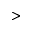Convert formula to latex. <formula><loc_0><loc_0><loc_500><loc_500>></formula> 